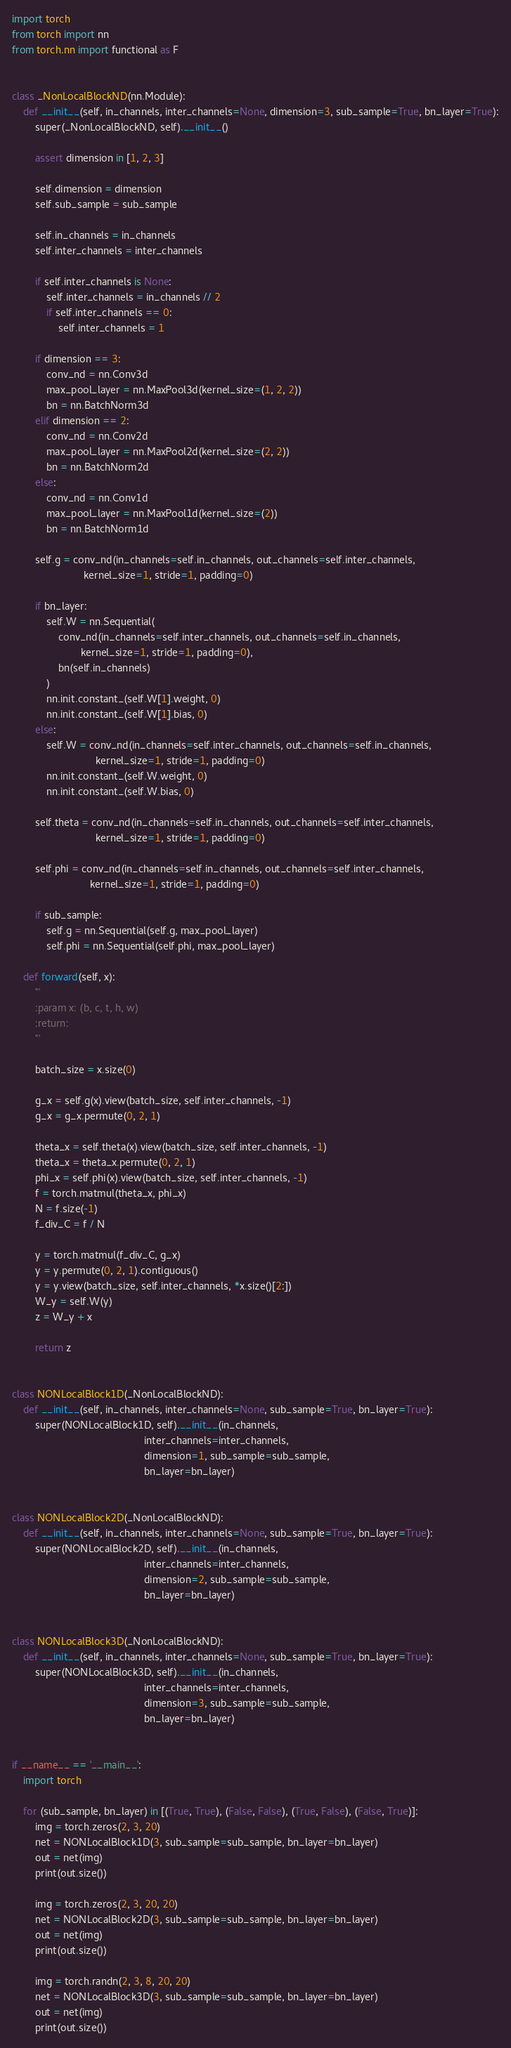<code> <loc_0><loc_0><loc_500><loc_500><_Python_>import torch
from torch import nn
from torch.nn import functional as F


class _NonLocalBlockND(nn.Module):
    def __init__(self, in_channels, inter_channels=None, dimension=3, sub_sample=True, bn_layer=True):
        super(_NonLocalBlockND, self).__init__()

        assert dimension in [1, 2, 3]

        self.dimension = dimension
        self.sub_sample = sub_sample

        self.in_channels = in_channels
        self.inter_channels = inter_channels

        if self.inter_channels is None:
            self.inter_channels = in_channels // 2
            if self.inter_channels == 0:
                self.inter_channels = 1

        if dimension == 3:
            conv_nd = nn.Conv3d
            max_pool_layer = nn.MaxPool3d(kernel_size=(1, 2, 2))
            bn = nn.BatchNorm3d
        elif dimension == 2:
            conv_nd = nn.Conv2d
            max_pool_layer = nn.MaxPool2d(kernel_size=(2, 2))
            bn = nn.BatchNorm2d
        else:
            conv_nd = nn.Conv1d
            max_pool_layer = nn.MaxPool1d(kernel_size=(2))
            bn = nn.BatchNorm1d

        self.g = conv_nd(in_channels=self.in_channels, out_channels=self.inter_channels,
                         kernel_size=1, stride=1, padding=0)

        if bn_layer:
            self.W = nn.Sequential(
                conv_nd(in_channels=self.inter_channels, out_channels=self.in_channels,
                        kernel_size=1, stride=1, padding=0),
                bn(self.in_channels)
            )
            nn.init.constant_(self.W[1].weight, 0)
            nn.init.constant_(self.W[1].bias, 0)
        else:
            self.W = conv_nd(in_channels=self.inter_channels, out_channels=self.in_channels,
                             kernel_size=1, stride=1, padding=0)
            nn.init.constant_(self.W.weight, 0)
            nn.init.constant_(self.W.bias, 0)

        self.theta = conv_nd(in_channels=self.in_channels, out_channels=self.inter_channels,
                             kernel_size=1, stride=1, padding=0)

        self.phi = conv_nd(in_channels=self.in_channels, out_channels=self.inter_channels,
                           kernel_size=1, stride=1, padding=0)

        if sub_sample:
            self.g = nn.Sequential(self.g, max_pool_layer)
            self.phi = nn.Sequential(self.phi, max_pool_layer)

    def forward(self, x):
        '''
        :param x: (b, c, t, h, w)
        :return:
        '''

        batch_size = x.size(0)

        g_x = self.g(x).view(batch_size, self.inter_channels, -1)
        g_x = g_x.permute(0, 2, 1)

        theta_x = self.theta(x).view(batch_size, self.inter_channels, -1)
        theta_x = theta_x.permute(0, 2, 1)
        phi_x = self.phi(x).view(batch_size, self.inter_channels, -1)
        f = torch.matmul(theta_x, phi_x)
        N = f.size(-1)
        f_div_C = f / N

        y = torch.matmul(f_div_C, g_x)
        y = y.permute(0, 2, 1).contiguous()
        y = y.view(batch_size, self.inter_channels, *x.size()[2:])
        W_y = self.W(y)
        z = W_y + x

        return z


class NONLocalBlock1D(_NonLocalBlockND):
    def __init__(self, in_channels, inter_channels=None, sub_sample=True, bn_layer=True):
        super(NONLocalBlock1D, self).__init__(in_channels,
                                              inter_channels=inter_channels,
                                              dimension=1, sub_sample=sub_sample,
                                              bn_layer=bn_layer)


class NONLocalBlock2D(_NonLocalBlockND):
    def __init__(self, in_channels, inter_channels=None, sub_sample=True, bn_layer=True):
        super(NONLocalBlock2D, self).__init__(in_channels,
                                              inter_channels=inter_channels,
                                              dimension=2, sub_sample=sub_sample,
                                              bn_layer=bn_layer)


class NONLocalBlock3D(_NonLocalBlockND):
    def __init__(self, in_channels, inter_channels=None, sub_sample=True, bn_layer=True):
        super(NONLocalBlock3D, self).__init__(in_channels,
                                              inter_channels=inter_channels,
                                              dimension=3, sub_sample=sub_sample,
                                              bn_layer=bn_layer)


if __name__ == '__main__':
    import torch

    for (sub_sample, bn_layer) in [(True, True), (False, False), (True, False), (False, True)]:
        img = torch.zeros(2, 3, 20)
        net = NONLocalBlock1D(3, sub_sample=sub_sample, bn_layer=bn_layer)
        out = net(img)
        print(out.size())

        img = torch.zeros(2, 3, 20, 20)
        net = NONLocalBlock2D(3, sub_sample=sub_sample, bn_layer=bn_layer)
        out = net(img)
        print(out.size())

        img = torch.randn(2, 3, 8, 20, 20)
        net = NONLocalBlock3D(3, sub_sample=sub_sample, bn_layer=bn_layer)
        out = net(img)
        print(out.size())



</code> 